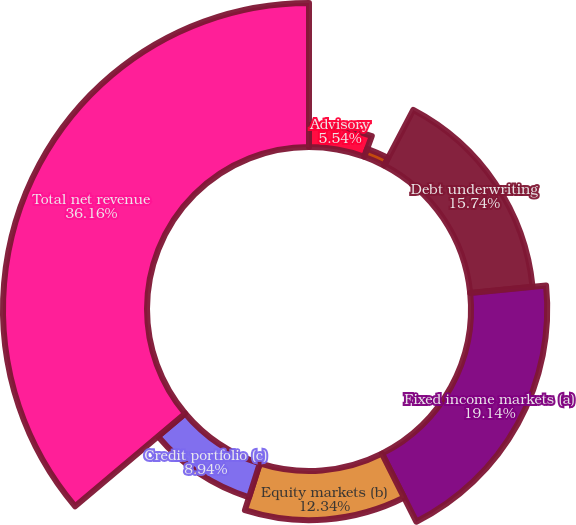Convert chart to OTSL. <chart><loc_0><loc_0><loc_500><loc_500><pie_chart><fcel>Advisory<fcel>Equity underwriting<fcel>Debt underwriting<fcel>Fixed income markets (a)<fcel>Equity markets (b)<fcel>Credit portfolio (c)<fcel>Total net revenue<nl><fcel>5.54%<fcel>2.14%<fcel>15.74%<fcel>19.14%<fcel>12.34%<fcel>8.94%<fcel>36.15%<nl></chart> 